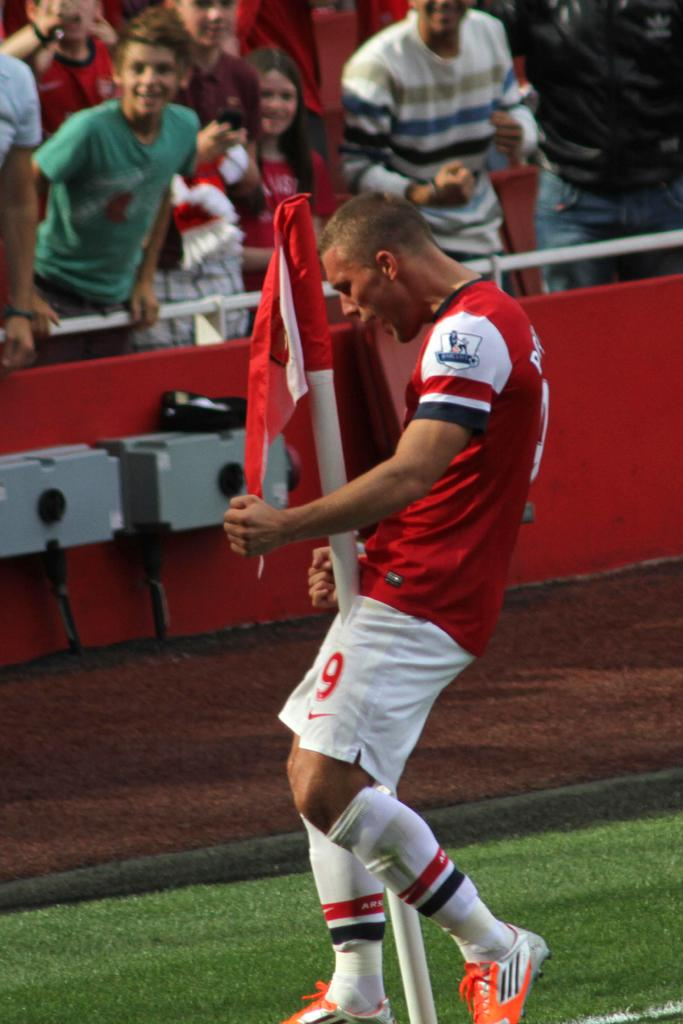What is the main subject of the image? There is a person in the image. What can be seen near the person? There is a pole with a flag in the image. What is happening in the background of the image? There is a group of people in the background of the image, along with other objects. What type of brake can be seen on the person in the image? There is no brake visible on the person in the image. What town is depicted in the background of the image? The image does not show a town; it only shows a group of people and other objects in the background. 